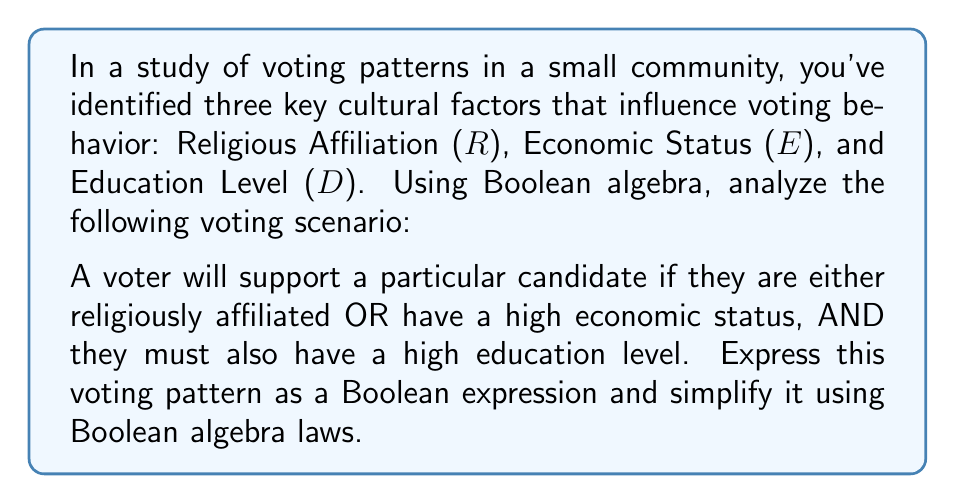Give your solution to this math problem. Let's approach this step-by-step:

1) First, we need to translate the voting pattern into a Boolean expression:
   $$(R \lor E) \land D$$
   
   Where:
   $R$ = Religious Affiliation
   $E$ = High Economic Status
   $D$ = High Education Level
   $\lor$ represents OR
   $\land$ represents AND

2) This expression is already in its simplest form according to the given conditions. However, we can demonstrate the use of Boolean algebra laws to verify this:

3) We can apply the distributive law: $A \land (B \lor C) = (A \land B) \lor (A \land C)$
   
   $$(R \lor E) \land D = (R \land D) \lor (E \land D)$$

4) This expanded form shows that a voter will support the candidate if:
   - They are religiously affiliated AND have a high education level, OR
   - They have a high economic status AND have a high education level

5) We can't simplify this further because we don't have any additional information about the relationships between these factors.

From an anthropological perspective, this Boolean expression represents a cultural voting pattern where education level is a crucial factor, combined with either religious affiliation or economic status. This could reflect a community that highly values education while also recognizing the influence of religious institutions or economic class on political preferences.
Answer: $$(R \lor E) \land D$$ 